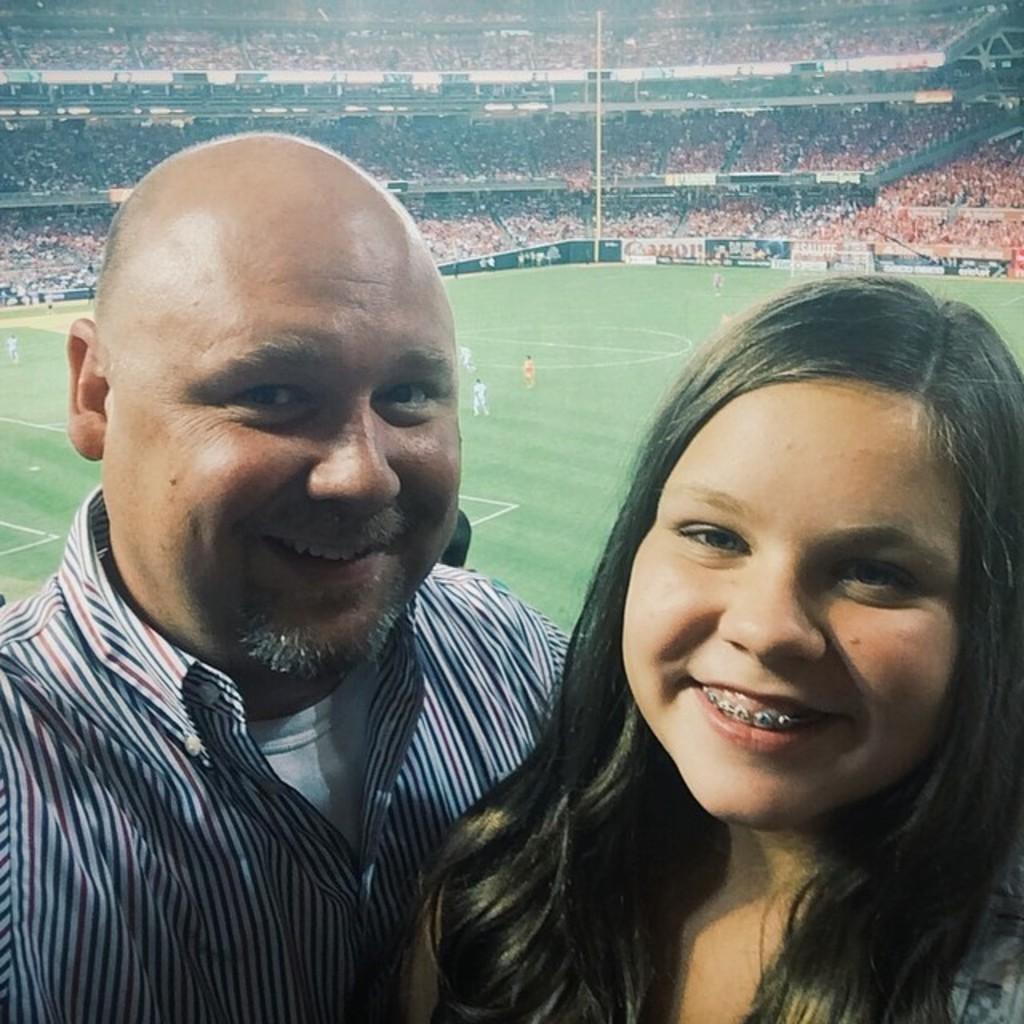Can you describe this image briefly? In this image I can see two people smiling. In the background I can see few people are on the ground. To the side of these people I can see the boards. And there are many people in the stadium. 